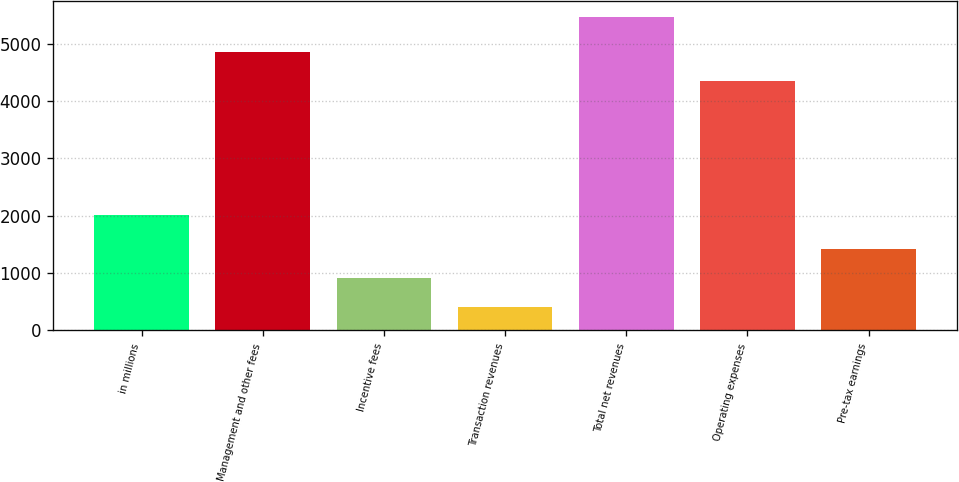Convert chart. <chart><loc_0><loc_0><loc_500><loc_500><bar_chart><fcel>in millions<fcel>Management and other fees<fcel>Incentive fees<fcel>Transaction revenues<fcel>Total net revenues<fcel>Operating expenses<fcel>Pre-tax earnings<nl><fcel>2013<fcel>4861.8<fcel>919.8<fcel>415<fcel>5463<fcel>4357<fcel>1424.6<nl></chart> 